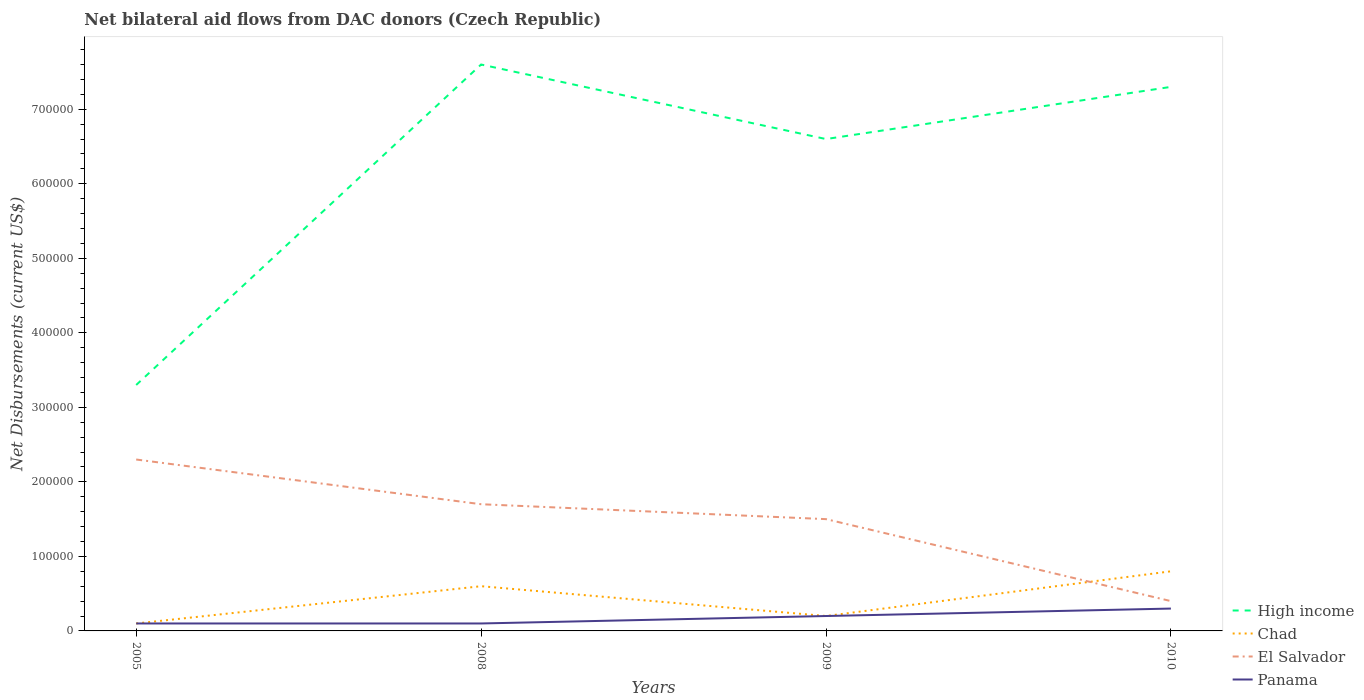How many different coloured lines are there?
Give a very brief answer. 4. Does the line corresponding to Chad intersect with the line corresponding to El Salvador?
Your answer should be very brief. Yes. Across all years, what is the maximum net bilateral aid flows in El Salvador?
Make the answer very short. 4.00e+04. What is the total net bilateral aid flows in El Salvador in the graph?
Provide a succinct answer. 2.00e+04. What is the difference between the highest and the second highest net bilateral aid flows in Panama?
Your answer should be compact. 2.00e+04. Is the net bilateral aid flows in High income strictly greater than the net bilateral aid flows in El Salvador over the years?
Give a very brief answer. No. What is the difference between two consecutive major ticks on the Y-axis?
Ensure brevity in your answer.  1.00e+05. Does the graph contain any zero values?
Ensure brevity in your answer.  No. Where does the legend appear in the graph?
Offer a very short reply. Bottom right. What is the title of the graph?
Ensure brevity in your answer.  Net bilateral aid flows from DAC donors (Czech Republic). Does "Mexico" appear as one of the legend labels in the graph?
Make the answer very short. No. What is the label or title of the X-axis?
Offer a terse response. Years. What is the label or title of the Y-axis?
Your answer should be compact. Net Disbursements (current US$). What is the Net Disbursements (current US$) of High income in 2005?
Give a very brief answer. 3.30e+05. What is the Net Disbursements (current US$) of Chad in 2005?
Ensure brevity in your answer.  10000. What is the Net Disbursements (current US$) in El Salvador in 2005?
Your answer should be compact. 2.30e+05. What is the Net Disbursements (current US$) of Panama in 2005?
Your answer should be very brief. 10000. What is the Net Disbursements (current US$) in High income in 2008?
Your answer should be compact. 7.60e+05. What is the Net Disbursements (current US$) in Panama in 2008?
Keep it short and to the point. 10000. What is the Net Disbursements (current US$) in High income in 2009?
Keep it short and to the point. 6.60e+05. What is the Net Disbursements (current US$) in Chad in 2009?
Your answer should be very brief. 2.00e+04. What is the Net Disbursements (current US$) of Panama in 2009?
Offer a very short reply. 2.00e+04. What is the Net Disbursements (current US$) of High income in 2010?
Offer a very short reply. 7.30e+05. What is the Net Disbursements (current US$) of Chad in 2010?
Keep it short and to the point. 8.00e+04. What is the Net Disbursements (current US$) in El Salvador in 2010?
Make the answer very short. 4.00e+04. Across all years, what is the maximum Net Disbursements (current US$) in High income?
Provide a succinct answer. 7.60e+05. Across all years, what is the maximum Net Disbursements (current US$) of El Salvador?
Keep it short and to the point. 2.30e+05. Across all years, what is the minimum Net Disbursements (current US$) in El Salvador?
Your response must be concise. 4.00e+04. What is the total Net Disbursements (current US$) of High income in the graph?
Your response must be concise. 2.48e+06. What is the total Net Disbursements (current US$) of El Salvador in the graph?
Your response must be concise. 5.90e+05. What is the total Net Disbursements (current US$) in Panama in the graph?
Provide a succinct answer. 7.00e+04. What is the difference between the Net Disbursements (current US$) in High income in 2005 and that in 2008?
Your answer should be very brief. -4.30e+05. What is the difference between the Net Disbursements (current US$) of Chad in 2005 and that in 2008?
Your answer should be compact. -5.00e+04. What is the difference between the Net Disbursements (current US$) in High income in 2005 and that in 2009?
Provide a succinct answer. -3.30e+05. What is the difference between the Net Disbursements (current US$) of Panama in 2005 and that in 2009?
Give a very brief answer. -10000. What is the difference between the Net Disbursements (current US$) in High income in 2005 and that in 2010?
Give a very brief answer. -4.00e+05. What is the difference between the Net Disbursements (current US$) in El Salvador in 2005 and that in 2010?
Offer a terse response. 1.90e+05. What is the difference between the Net Disbursements (current US$) in Panama in 2005 and that in 2010?
Keep it short and to the point. -2.00e+04. What is the difference between the Net Disbursements (current US$) of High income in 2008 and that in 2009?
Your answer should be very brief. 1.00e+05. What is the difference between the Net Disbursements (current US$) of Chad in 2008 and that in 2009?
Your answer should be compact. 4.00e+04. What is the difference between the Net Disbursements (current US$) in El Salvador in 2008 and that in 2009?
Provide a succinct answer. 2.00e+04. What is the difference between the Net Disbursements (current US$) of Panama in 2008 and that in 2009?
Your answer should be very brief. -10000. What is the difference between the Net Disbursements (current US$) in Chad in 2008 and that in 2010?
Ensure brevity in your answer.  -2.00e+04. What is the difference between the Net Disbursements (current US$) in Panama in 2008 and that in 2010?
Keep it short and to the point. -2.00e+04. What is the difference between the Net Disbursements (current US$) in El Salvador in 2009 and that in 2010?
Give a very brief answer. 1.10e+05. What is the difference between the Net Disbursements (current US$) in Panama in 2009 and that in 2010?
Offer a very short reply. -10000. What is the difference between the Net Disbursements (current US$) in High income in 2005 and the Net Disbursements (current US$) in Chad in 2008?
Offer a very short reply. 2.70e+05. What is the difference between the Net Disbursements (current US$) of Chad in 2005 and the Net Disbursements (current US$) of Panama in 2008?
Provide a short and direct response. 0. What is the difference between the Net Disbursements (current US$) in El Salvador in 2005 and the Net Disbursements (current US$) in Panama in 2008?
Make the answer very short. 2.20e+05. What is the difference between the Net Disbursements (current US$) in High income in 2005 and the Net Disbursements (current US$) in Chad in 2009?
Offer a very short reply. 3.10e+05. What is the difference between the Net Disbursements (current US$) in High income in 2005 and the Net Disbursements (current US$) in El Salvador in 2009?
Ensure brevity in your answer.  1.80e+05. What is the difference between the Net Disbursements (current US$) of Chad in 2005 and the Net Disbursements (current US$) of El Salvador in 2009?
Your answer should be compact. -1.40e+05. What is the difference between the Net Disbursements (current US$) of High income in 2005 and the Net Disbursements (current US$) of Panama in 2010?
Offer a terse response. 3.00e+05. What is the difference between the Net Disbursements (current US$) of High income in 2008 and the Net Disbursements (current US$) of Chad in 2009?
Provide a succinct answer. 7.40e+05. What is the difference between the Net Disbursements (current US$) of High income in 2008 and the Net Disbursements (current US$) of Panama in 2009?
Make the answer very short. 7.40e+05. What is the difference between the Net Disbursements (current US$) in Chad in 2008 and the Net Disbursements (current US$) in El Salvador in 2009?
Offer a terse response. -9.00e+04. What is the difference between the Net Disbursements (current US$) of Chad in 2008 and the Net Disbursements (current US$) of Panama in 2009?
Provide a succinct answer. 4.00e+04. What is the difference between the Net Disbursements (current US$) in El Salvador in 2008 and the Net Disbursements (current US$) in Panama in 2009?
Give a very brief answer. 1.50e+05. What is the difference between the Net Disbursements (current US$) of High income in 2008 and the Net Disbursements (current US$) of Chad in 2010?
Your response must be concise. 6.80e+05. What is the difference between the Net Disbursements (current US$) of High income in 2008 and the Net Disbursements (current US$) of El Salvador in 2010?
Provide a short and direct response. 7.20e+05. What is the difference between the Net Disbursements (current US$) of High income in 2008 and the Net Disbursements (current US$) of Panama in 2010?
Provide a succinct answer. 7.30e+05. What is the difference between the Net Disbursements (current US$) in Chad in 2008 and the Net Disbursements (current US$) in El Salvador in 2010?
Keep it short and to the point. 2.00e+04. What is the difference between the Net Disbursements (current US$) in Chad in 2008 and the Net Disbursements (current US$) in Panama in 2010?
Your answer should be compact. 3.00e+04. What is the difference between the Net Disbursements (current US$) of El Salvador in 2008 and the Net Disbursements (current US$) of Panama in 2010?
Your answer should be very brief. 1.40e+05. What is the difference between the Net Disbursements (current US$) in High income in 2009 and the Net Disbursements (current US$) in Chad in 2010?
Your response must be concise. 5.80e+05. What is the difference between the Net Disbursements (current US$) in High income in 2009 and the Net Disbursements (current US$) in El Salvador in 2010?
Your answer should be very brief. 6.20e+05. What is the difference between the Net Disbursements (current US$) in High income in 2009 and the Net Disbursements (current US$) in Panama in 2010?
Your response must be concise. 6.30e+05. What is the average Net Disbursements (current US$) of High income per year?
Give a very brief answer. 6.20e+05. What is the average Net Disbursements (current US$) of Chad per year?
Ensure brevity in your answer.  4.25e+04. What is the average Net Disbursements (current US$) of El Salvador per year?
Provide a succinct answer. 1.48e+05. What is the average Net Disbursements (current US$) of Panama per year?
Provide a succinct answer. 1.75e+04. In the year 2005, what is the difference between the Net Disbursements (current US$) of High income and Net Disbursements (current US$) of Chad?
Offer a very short reply. 3.20e+05. In the year 2005, what is the difference between the Net Disbursements (current US$) of Chad and Net Disbursements (current US$) of El Salvador?
Your answer should be very brief. -2.20e+05. In the year 2008, what is the difference between the Net Disbursements (current US$) in High income and Net Disbursements (current US$) in El Salvador?
Provide a succinct answer. 5.90e+05. In the year 2008, what is the difference between the Net Disbursements (current US$) in High income and Net Disbursements (current US$) in Panama?
Ensure brevity in your answer.  7.50e+05. In the year 2008, what is the difference between the Net Disbursements (current US$) in Chad and Net Disbursements (current US$) in Panama?
Your answer should be compact. 5.00e+04. In the year 2009, what is the difference between the Net Disbursements (current US$) of High income and Net Disbursements (current US$) of Chad?
Keep it short and to the point. 6.40e+05. In the year 2009, what is the difference between the Net Disbursements (current US$) of High income and Net Disbursements (current US$) of El Salvador?
Keep it short and to the point. 5.10e+05. In the year 2009, what is the difference between the Net Disbursements (current US$) of High income and Net Disbursements (current US$) of Panama?
Give a very brief answer. 6.40e+05. In the year 2009, what is the difference between the Net Disbursements (current US$) of Chad and Net Disbursements (current US$) of Panama?
Keep it short and to the point. 0. In the year 2010, what is the difference between the Net Disbursements (current US$) in High income and Net Disbursements (current US$) in Chad?
Provide a short and direct response. 6.50e+05. In the year 2010, what is the difference between the Net Disbursements (current US$) in High income and Net Disbursements (current US$) in El Salvador?
Give a very brief answer. 6.90e+05. In the year 2010, what is the difference between the Net Disbursements (current US$) of High income and Net Disbursements (current US$) of Panama?
Keep it short and to the point. 7.00e+05. In the year 2010, what is the difference between the Net Disbursements (current US$) in Chad and Net Disbursements (current US$) in El Salvador?
Your answer should be compact. 4.00e+04. In the year 2010, what is the difference between the Net Disbursements (current US$) of El Salvador and Net Disbursements (current US$) of Panama?
Make the answer very short. 10000. What is the ratio of the Net Disbursements (current US$) in High income in 2005 to that in 2008?
Offer a very short reply. 0.43. What is the ratio of the Net Disbursements (current US$) in El Salvador in 2005 to that in 2008?
Your answer should be compact. 1.35. What is the ratio of the Net Disbursements (current US$) of Panama in 2005 to that in 2008?
Offer a very short reply. 1. What is the ratio of the Net Disbursements (current US$) of Chad in 2005 to that in 2009?
Give a very brief answer. 0.5. What is the ratio of the Net Disbursements (current US$) in El Salvador in 2005 to that in 2009?
Your answer should be very brief. 1.53. What is the ratio of the Net Disbursements (current US$) in Panama in 2005 to that in 2009?
Provide a succinct answer. 0.5. What is the ratio of the Net Disbursements (current US$) of High income in 2005 to that in 2010?
Your answer should be compact. 0.45. What is the ratio of the Net Disbursements (current US$) of Chad in 2005 to that in 2010?
Keep it short and to the point. 0.12. What is the ratio of the Net Disbursements (current US$) of El Salvador in 2005 to that in 2010?
Your answer should be very brief. 5.75. What is the ratio of the Net Disbursements (current US$) of High income in 2008 to that in 2009?
Offer a very short reply. 1.15. What is the ratio of the Net Disbursements (current US$) of El Salvador in 2008 to that in 2009?
Your answer should be very brief. 1.13. What is the ratio of the Net Disbursements (current US$) in Panama in 2008 to that in 2009?
Your answer should be very brief. 0.5. What is the ratio of the Net Disbursements (current US$) in High income in 2008 to that in 2010?
Offer a very short reply. 1.04. What is the ratio of the Net Disbursements (current US$) in El Salvador in 2008 to that in 2010?
Provide a succinct answer. 4.25. What is the ratio of the Net Disbursements (current US$) of Panama in 2008 to that in 2010?
Provide a short and direct response. 0.33. What is the ratio of the Net Disbursements (current US$) of High income in 2009 to that in 2010?
Make the answer very short. 0.9. What is the ratio of the Net Disbursements (current US$) of Chad in 2009 to that in 2010?
Make the answer very short. 0.25. What is the ratio of the Net Disbursements (current US$) in El Salvador in 2009 to that in 2010?
Your answer should be very brief. 3.75. What is the difference between the highest and the second highest Net Disbursements (current US$) of High income?
Your answer should be compact. 3.00e+04. What is the difference between the highest and the second highest Net Disbursements (current US$) of El Salvador?
Offer a terse response. 6.00e+04. What is the difference between the highest and the second highest Net Disbursements (current US$) of Panama?
Provide a short and direct response. 10000. What is the difference between the highest and the lowest Net Disbursements (current US$) of Chad?
Ensure brevity in your answer.  7.00e+04. What is the difference between the highest and the lowest Net Disbursements (current US$) in Panama?
Offer a very short reply. 2.00e+04. 